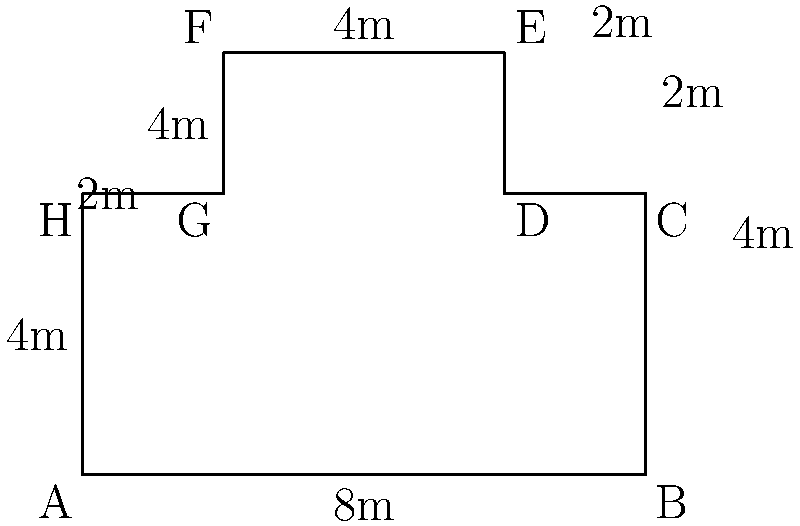As a museum exhibit technician, you're tasked with calculating the perimeter of an irregular polygon-shaped exhibit floor plan. The floor plan is shown in the diagram above, with measurements provided in meters. What is the total perimeter of this exhibit space? To calculate the perimeter of the irregular polygon, we need to sum up the lengths of all sides:

1. Side AB: $8$ m
2. Side BC: $4$ m
3. Side CD: $2$ m
4. Side DE: $2$ m
5. Side EF: $4$ m
6. Side FG: $4$ m
7. Side GH: $2$ m
8. Side HA: $4$ m

Total perimeter = $8 + 4 + 2 + 2 + 4 + 4 + 2 + 4 = 30$ m

Therefore, the total perimeter of the exhibit space is 30 meters.
Answer: $30$ m 